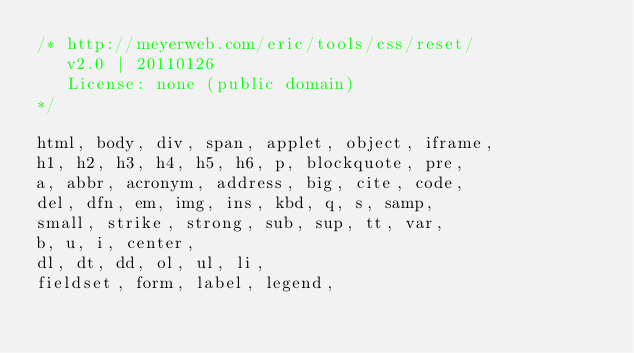<code> <loc_0><loc_0><loc_500><loc_500><_CSS_>/* http://meyerweb.com/eric/tools/css/reset/ 
   v2.0 | 20110126
   License: none (public domain)
*/

html, body, div, span, applet, object, iframe,
h1, h2, h3, h4, h5, h6, p, blockquote, pre,
a, abbr, acronym, address, big, cite, code,
del, dfn, em, img, ins, kbd, q, s, samp,
small, strike, strong, sub, sup, tt, var,
b, u, i, center,
dl, dt, dd, ol, ul, li,
fieldset, form, label, legend,</code> 